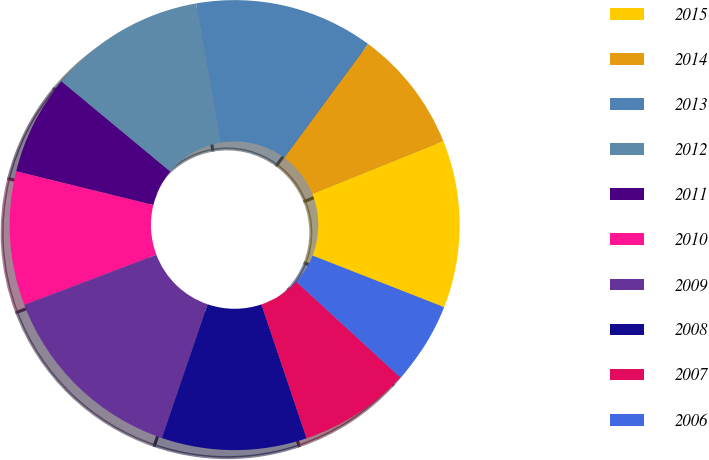<chart> <loc_0><loc_0><loc_500><loc_500><pie_chart><fcel>2015<fcel>2014<fcel>2013<fcel>2012<fcel>2011<fcel>2010<fcel>2009<fcel>2008<fcel>2007<fcel>2006<nl><fcel>12.04%<fcel>8.8%<fcel>12.85%<fcel>11.23%<fcel>7.18%<fcel>9.61%<fcel>13.99%<fcel>10.42%<fcel>7.99%<fcel>5.88%<nl></chart> 